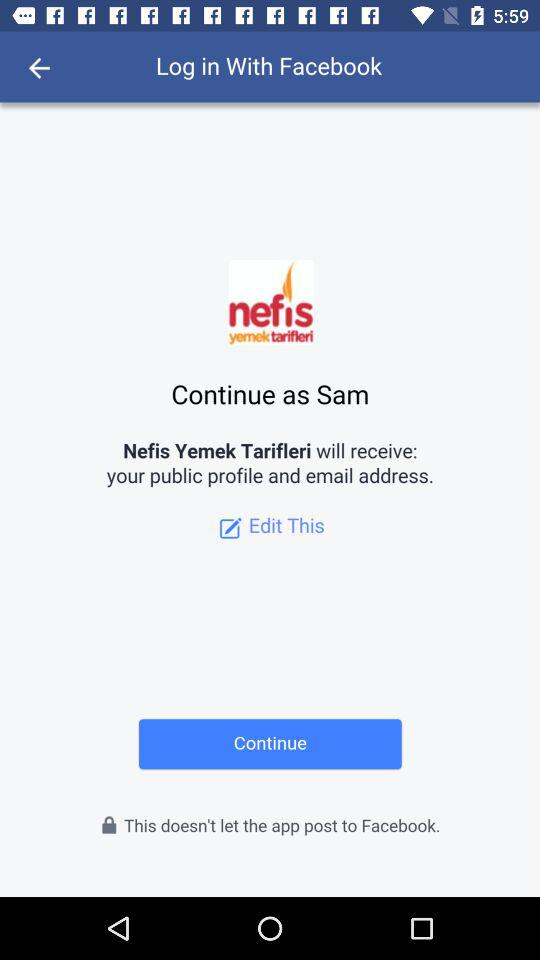What application is asking for permission? The application is "Nefis Yemek Tarifleri". 